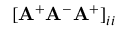Convert formula to latex. <formula><loc_0><loc_0><loc_500><loc_500>[ A ^ { + } A ^ { - } A ^ { + } ] _ { i i }</formula> 